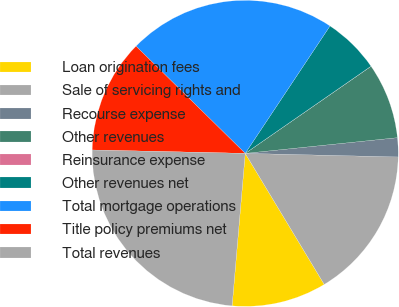Convert chart. <chart><loc_0><loc_0><loc_500><loc_500><pie_chart><fcel>Loan origination fees<fcel>Sale of servicing rights and<fcel>Recourse expense<fcel>Other revenues<fcel>Reinsurance expense<fcel>Other revenues net<fcel>Total mortgage operations<fcel>Title policy premiums net<fcel>Total revenues<nl><fcel>10.0%<fcel>15.99%<fcel>2.01%<fcel>8.0%<fcel>0.01%<fcel>6.01%<fcel>21.99%<fcel>12.0%<fcel>23.99%<nl></chart> 